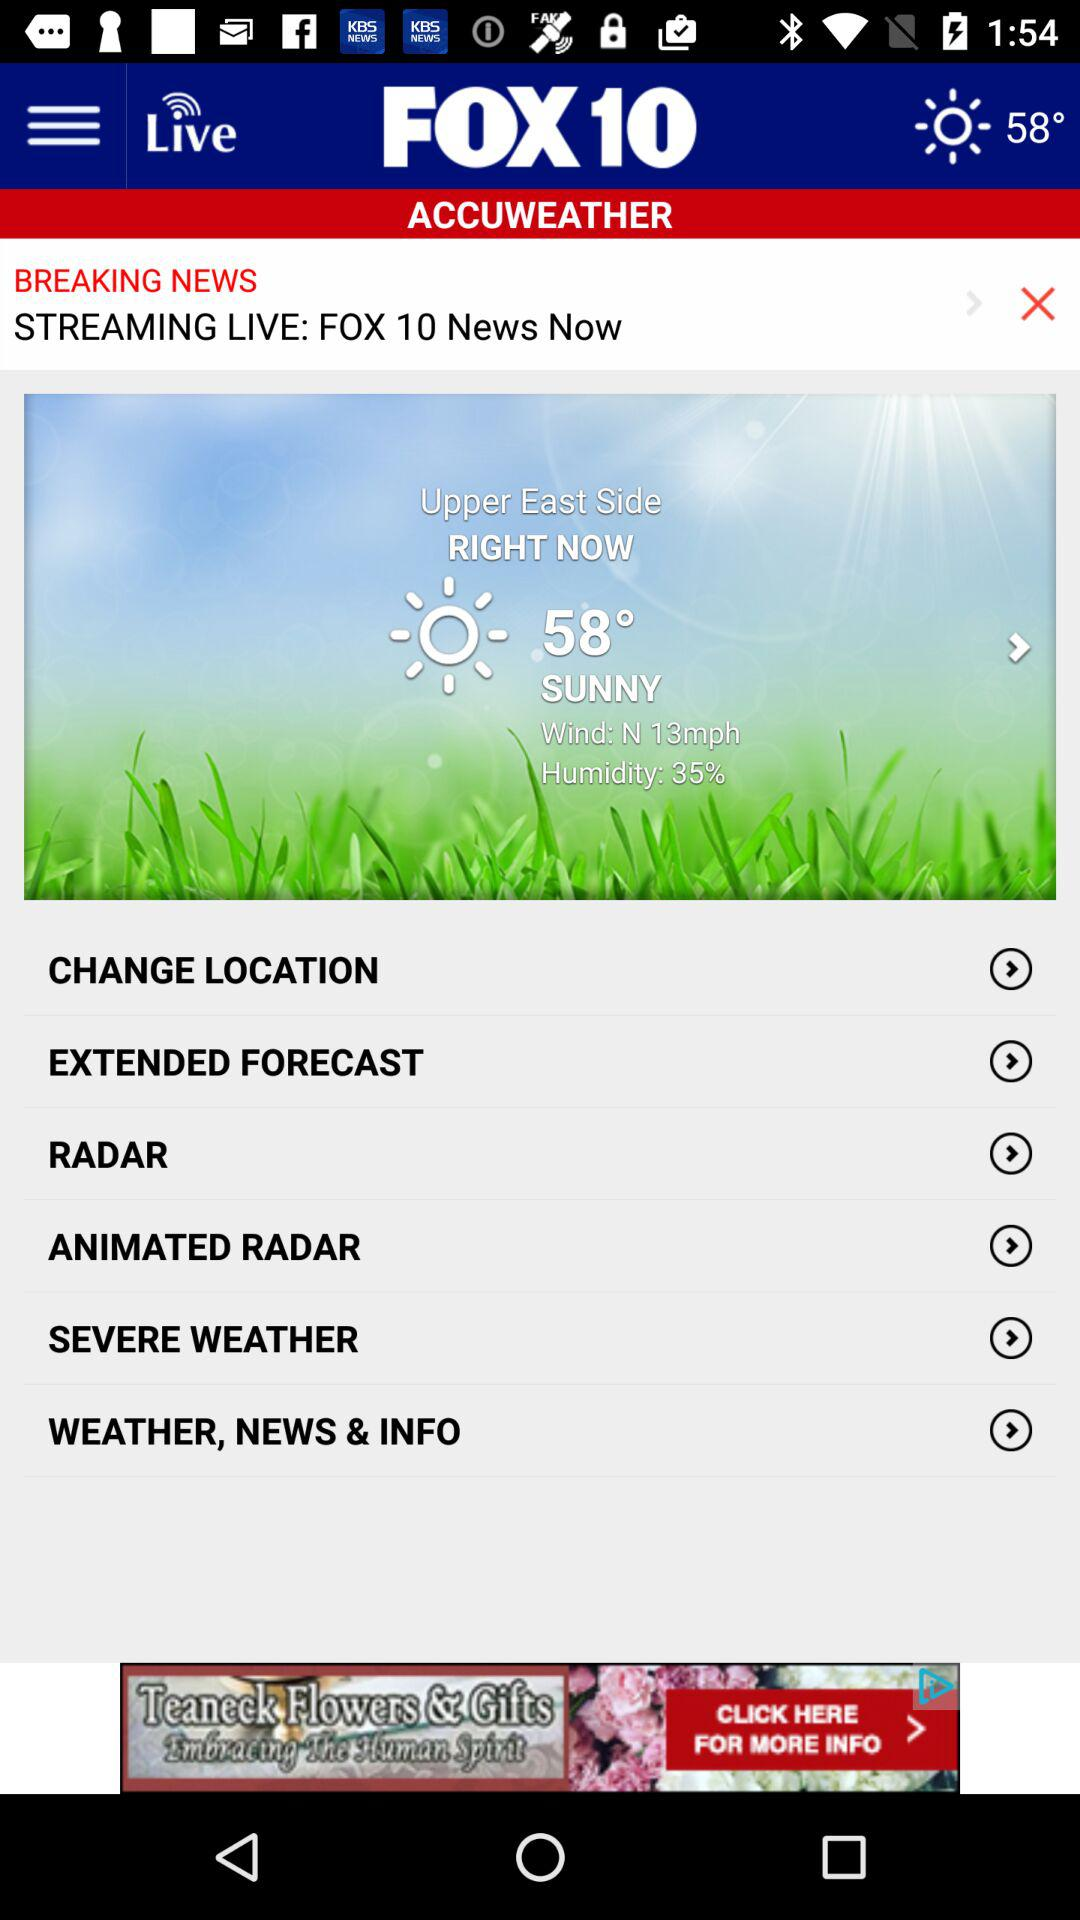What is the current temperature? The current temperature is 58°. 